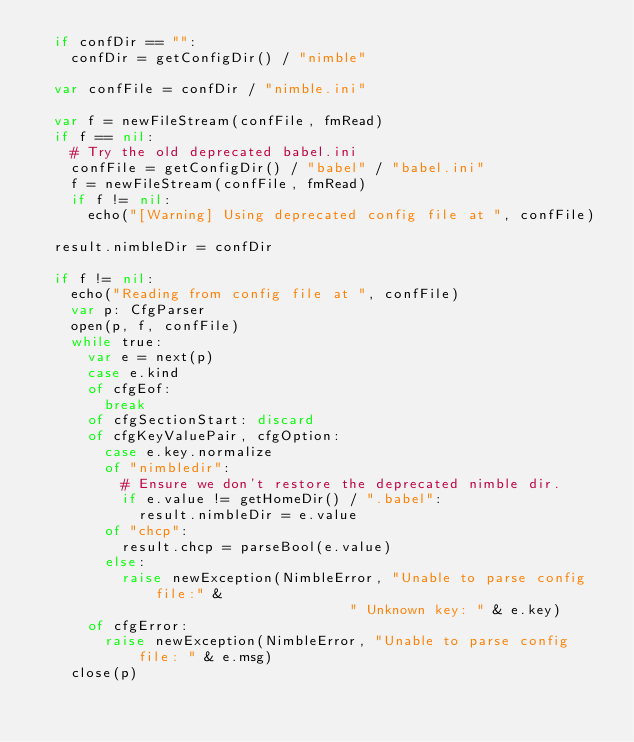Convert code to text. <code><loc_0><loc_0><loc_500><loc_500><_Nim_>  if confDir == "":
    confDir = getConfigDir() / "nimble"

  var confFile = confDir / "nimble.ini"

  var f = newFileStream(confFile, fmRead)
  if f == nil:
    # Try the old deprecated babel.ini
    confFile = getConfigDir() / "babel" / "babel.ini"
    f = newFileStream(confFile, fmRead)
    if f != nil:
      echo("[Warning] Using deprecated config file at ", confFile)

  result.nimbleDir = confDir

  if f != nil:
    echo("Reading from config file at ", confFile)
    var p: CfgParser
    open(p, f, confFile)
    while true:
      var e = next(p)
      case e.kind
      of cfgEof:
        break
      of cfgSectionStart: discard
      of cfgKeyValuePair, cfgOption:
        case e.key.normalize
        of "nimbledir":
          # Ensure we don't restore the deprecated nimble dir.
          if e.value != getHomeDir() / ".babel":
            result.nimbleDir = e.value
        of "chcp":
          result.chcp = parseBool(e.value)
        else:
          raise newException(NimbleError, "Unable to parse config file:" &
                                     " Unknown key: " & e.key)
      of cfgError:
        raise newException(NimbleError, "Unable to parse config file: " & e.msg)
    close(p)
</code> 